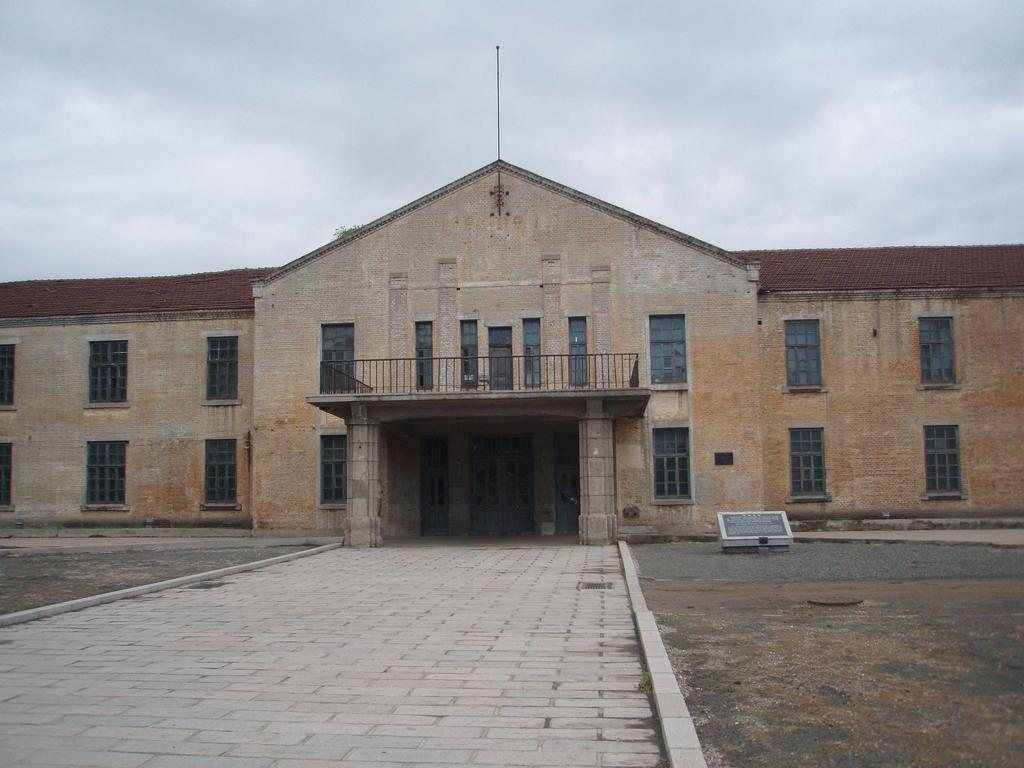What can be seen running through the image? There is a path in the image. What type of structure is present in the image? There is a building in the image. How many windows are visible in the image? There are multiple windows visible in the image. What is visible in the sky in the image? There are clouds in the sky, and the sky is visible in the image. Can you see a hook hanging from the clouds in the image? There is no hook hanging from the clouds in the image; only clouds and the sky are visible. Is there a monkey climbing on the building in the image? There is no monkey present in the image; only the building, windows, and path are visible. 